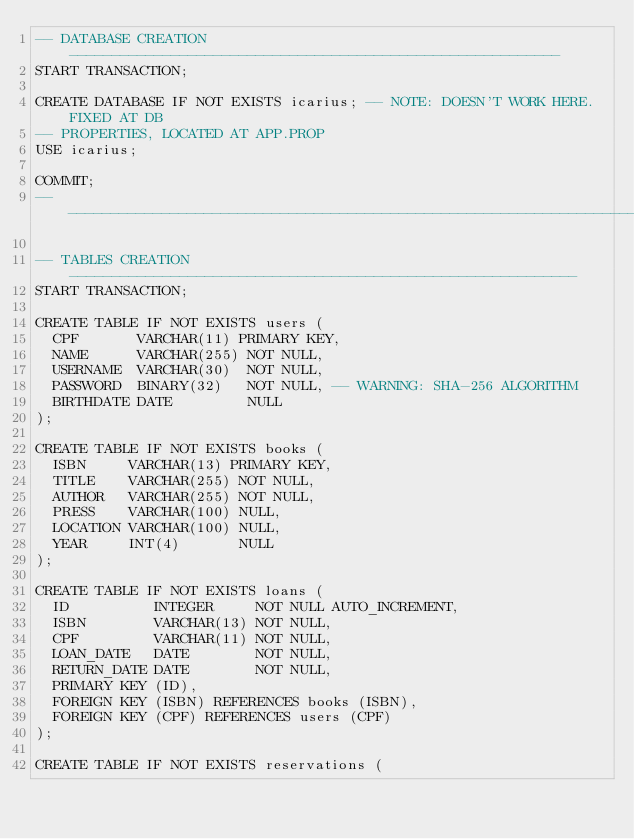Convert code to text. <code><loc_0><loc_0><loc_500><loc_500><_SQL_>-- DATABASE CREATION----------------------------------------------------------
START TRANSACTION;

CREATE DATABASE IF NOT EXISTS icarius; -- NOTE: DOESN'T WORK HERE. FIXED AT DB
-- PROPERTIES, LOCATED AT APP.PROP
USE icarius;

COMMIT;
-- ---------------------------------------------------------------------------

-- TABLES CREATION------------------------------------------------------------
START TRANSACTION;

CREATE TABLE IF NOT EXISTS users (
  CPF       VARCHAR(11) PRIMARY KEY,
  NAME      VARCHAR(255) NOT NULL,
  USERNAME  VARCHAR(30)  NOT NULL,
  PASSWORD  BINARY(32)   NOT NULL, -- WARNING: SHA-256 ALGORITHM
  BIRTHDATE DATE         NULL
);

CREATE TABLE IF NOT EXISTS books (
  ISBN     VARCHAR(13) PRIMARY KEY,
  TITLE    VARCHAR(255) NOT NULL,
  AUTHOR   VARCHAR(255) NOT NULL,
  PRESS    VARCHAR(100) NULL,
  LOCATION VARCHAR(100) NULL,
  YEAR     INT(4)       NULL
);

CREATE TABLE IF NOT EXISTS loans (
  ID          INTEGER     NOT NULL AUTO_INCREMENT,
  ISBN        VARCHAR(13) NOT NULL,
  CPF         VARCHAR(11) NOT NULL,
  LOAN_DATE   DATE        NOT NULL,
  RETURN_DATE DATE        NOT NULL,
  PRIMARY KEY (ID),
  FOREIGN KEY (ISBN) REFERENCES books (ISBN),
  FOREIGN KEY (CPF) REFERENCES users (CPF)
);

CREATE TABLE IF NOT EXISTS reservations (</code> 